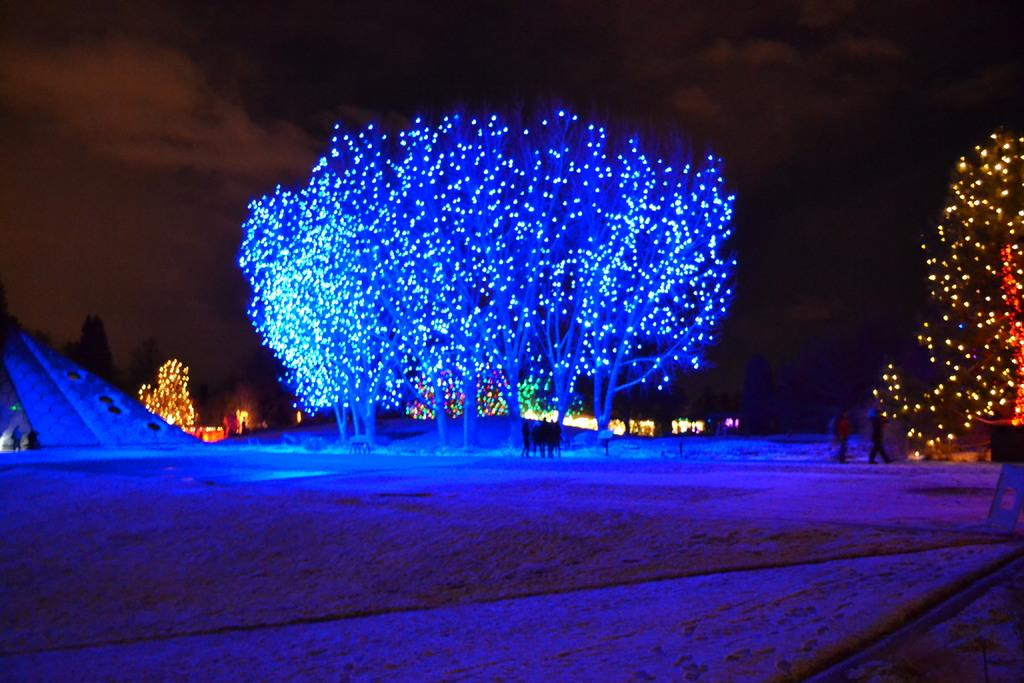What can be seen in the sky in the image? The sky with clouds is visible in the image. What type of lighting is present in the image? Decor lights are present in the image. What type of vegetation is visible in the image? Trees are visible in the image. What are the persons in the image doing? There are persons standing on the ground in the image. Can you tell me how many kitties are running around in the image? There are no kitties present in the image, and therefore no such activity can be observed. What invention is being demonstrated by the persons in the image? There is no invention being demonstrated by the persons in the image; they are simply standing on the ground. 